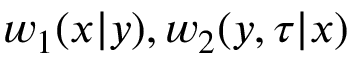Convert formula to latex. <formula><loc_0><loc_0><loc_500><loc_500>w _ { 1 } ( x | y ) , w _ { 2 } ( y , \tau | x )</formula> 